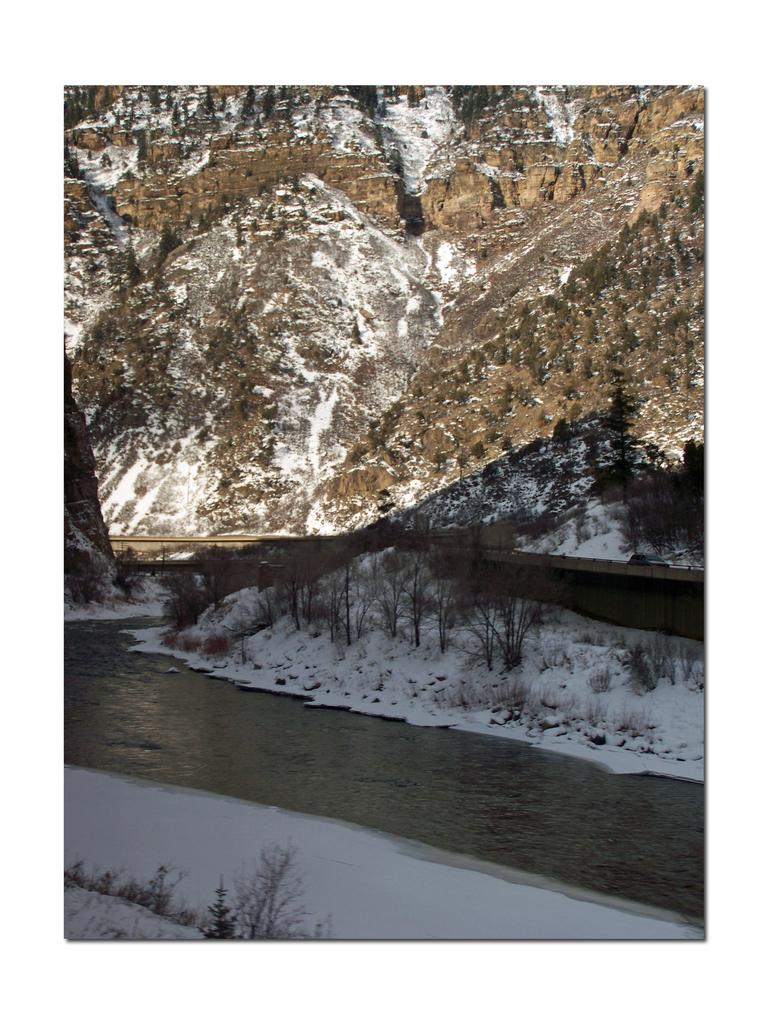What type of vegetation can be seen in the image? There are trees on the snow in the image. What is covering the ground in the image? The ground is covered in snow. What can be seen in the background of the image? There is water visible in the background of the image. What geographical feature is present at the top of the image? There is a mountain at the top of the image. Can you see a scarf being used to play volleyball in the image? There is no scarf or volleyball present in the image. What type of sack is visible on the mountain in the image? There is no sack visible on the mountain in the image. 